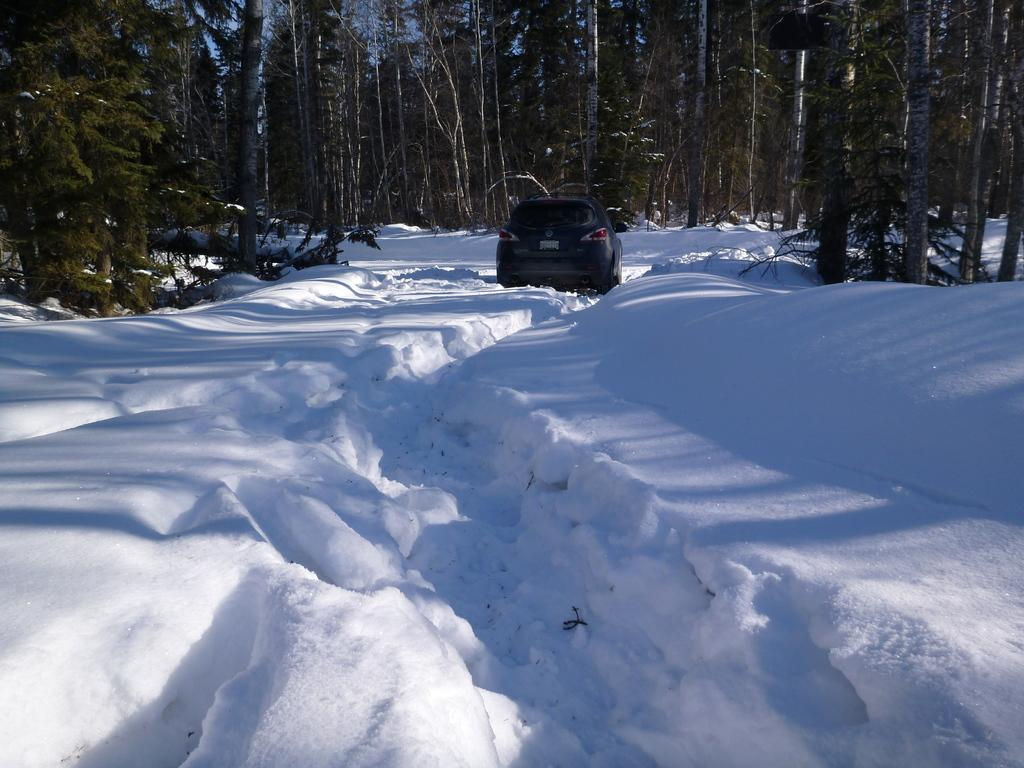What type of weather condition is depicted in the image? The image contains snow, indicating a wintery or cold weather condition. What type of vehicle is present in the image? There is a car in the image. What can be seen in the background of the image? There are trees in the background of the image. What color is the hydrant in the image? There is no hydrant present in the image. How many times does the person in the image sneeze? There is no person present in the image, so it is impossible to determine how many times they sneeze. 